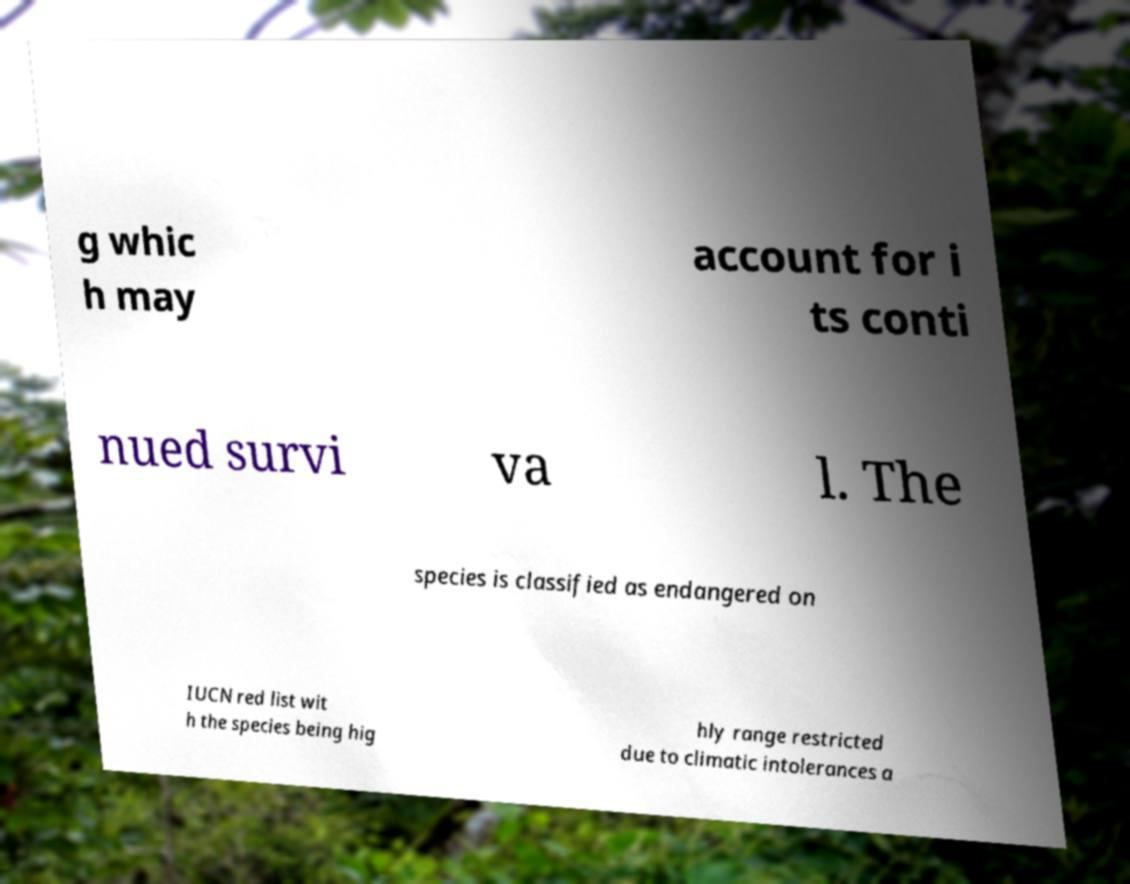There's text embedded in this image that I need extracted. Can you transcribe it verbatim? g whic h may account for i ts conti nued survi va l. The species is classified as endangered on IUCN red list wit h the species being hig hly range restricted due to climatic intolerances a 